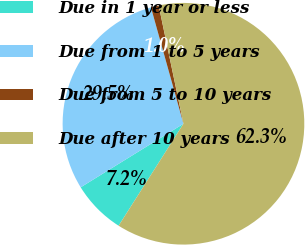<chart> <loc_0><loc_0><loc_500><loc_500><pie_chart><fcel>Due in 1 year or less<fcel>Due from 1 to 5 years<fcel>Due from 5 to 10 years<fcel>Due after 10 years<nl><fcel>7.17%<fcel>29.48%<fcel>1.05%<fcel>62.3%<nl></chart> 